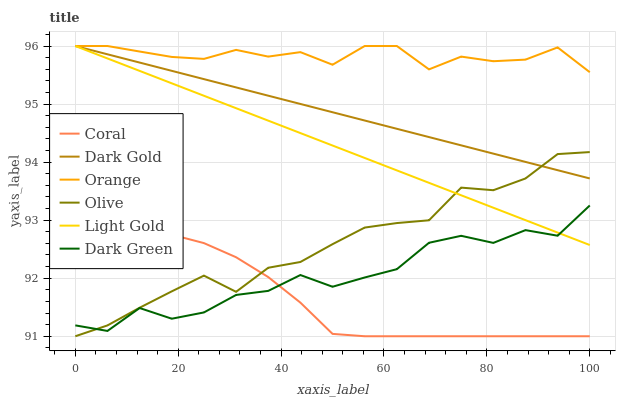Does Coral have the minimum area under the curve?
Answer yes or no. Yes. Does Orange have the maximum area under the curve?
Answer yes or no. Yes. Does Olive have the minimum area under the curve?
Answer yes or no. No. Does Olive have the maximum area under the curve?
Answer yes or no. No. Is Light Gold the smoothest?
Answer yes or no. Yes. Is Dark Green the roughest?
Answer yes or no. Yes. Is Coral the smoothest?
Answer yes or no. No. Is Coral the roughest?
Answer yes or no. No. Does Coral have the lowest value?
Answer yes or no. Yes. Does Orange have the lowest value?
Answer yes or no. No. Does Light Gold have the highest value?
Answer yes or no. Yes. Does Olive have the highest value?
Answer yes or no. No. Is Olive less than Orange?
Answer yes or no. Yes. Is Orange greater than Dark Green?
Answer yes or no. Yes. Does Dark Green intersect Olive?
Answer yes or no. Yes. Is Dark Green less than Olive?
Answer yes or no. No. Is Dark Green greater than Olive?
Answer yes or no. No. Does Olive intersect Orange?
Answer yes or no. No. 